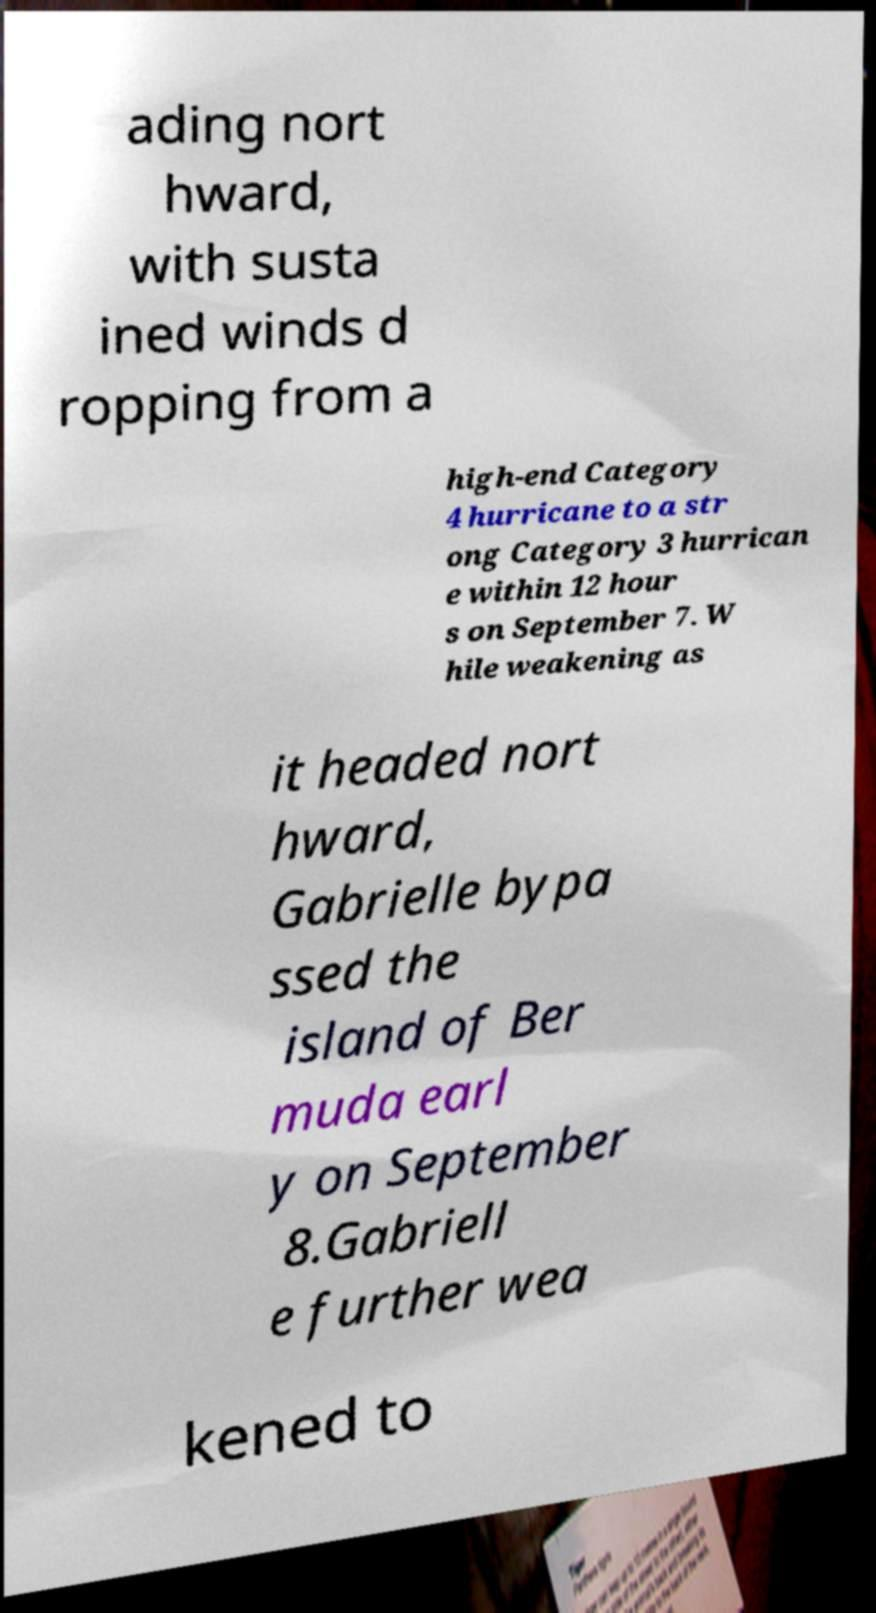For documentation purposes, I need the text within this image transcribed. Could you provide that? ading nort hward, with susta ined winds d ropping from a high-end Category 4 hurricane to a str ong Category 3 hurrican e within 12 hour s on September 7. W hile weakening as it headed nort hward, Gabrielle bypa ssed the island of Ber muda earl y on September 8.Gabriell e further wea kened to 